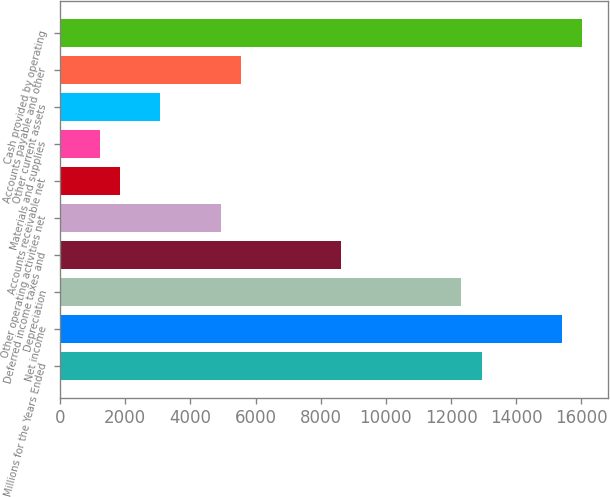Convert chart to OTSL. <chart><loc_0><loc_0><loc_500><loc_500><bar_chart><fcel>Millions for the Years Ended<fcel>Net income<fcel>Depreciation<fcel>Deferred income taxes and<fcel>Other operating activities net<fcel>Accounts receivable net<fcel>Materials and supplies<fcel>Other current assets<fcel>Accounts payable and other<fcel>Cash provided by operating<nl><fcel>12937<fcel>15401<fcel>12321<fcel>8625<fcel>4929<fcel>1849<fcel>1233<fcel>3081<fcel>5545<fcel>16017<nl></chart> 